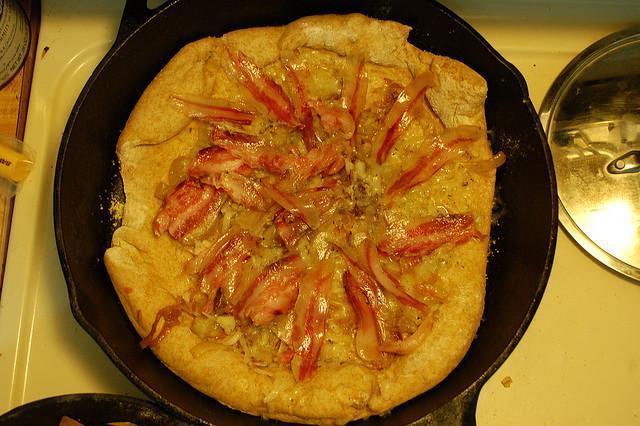How many people are wearing glasses?
Give a very brief answer. 0. 